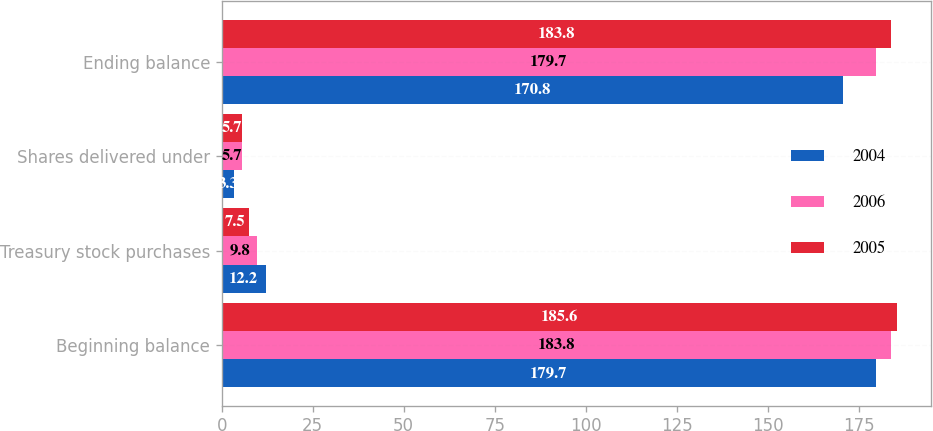Convert chart to OTSL. <chart><loc_0><loc_0><loc_500><loc_500><stacked_bar_chart><ecel><fcel>Beginning balance<fcel>Treasury stock purchases<fcel>Shares delivered under<fcel>Ending balance<nl><fcel>2004<fcel>179.7<fcel>12.2<fcel>3.3<fcel>170.8<nl><fcel>2006<fcel>183.8<fcel>9.8<fcel>5.7<fcel>179.7<nl><fcel>2005<fcel>185.6<fcel>7.5<fcel>5.7<fcel>183.8<nl></chart> 